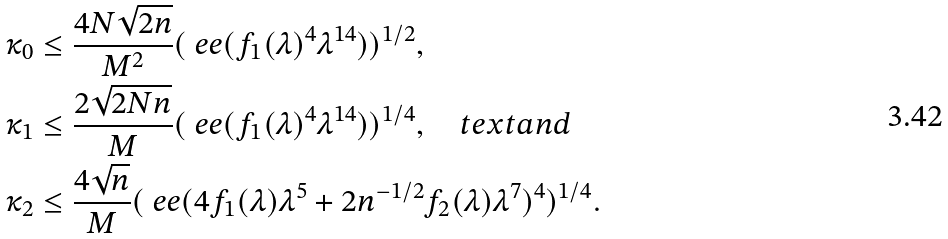<formula> <loc_0><loc_0><loc_500><loc_500>\kappa _ { 0 } & \leq \frac { 4 N \sqrt { 2 n } } { M ^ { 2 } } ( \ e e ( f _ { 1 } ( \lambda ) ^ { 4 } \lambda ^ { 1 4 } ) ) ^ { 1 / 2 } , \\ \kappa _ { 1 } & \leq \frac { 2 \sqrt { 2 N n } } { M } ( \ e e ( f _ { 1 } ( \lambda ) ^ { 4 } \lambda ^ { 1 4 } ) ) ^ { 1 / 4 } , \quad t e x t { a n d } \\ \kappa _ { 2 } & \leq \frac { 4 \sqrt { n } } { M } ( \ e e ( 4 f _ { 1 } ( \lambda ) \lambda ^ { 5 } + 2 n ^ { - 1 / 2 } f _ { 2 } ( \lambda ) \lambda ^ { 7 } ) ^ { 4 } ) ^ { 1 / 4 } .</formula> 